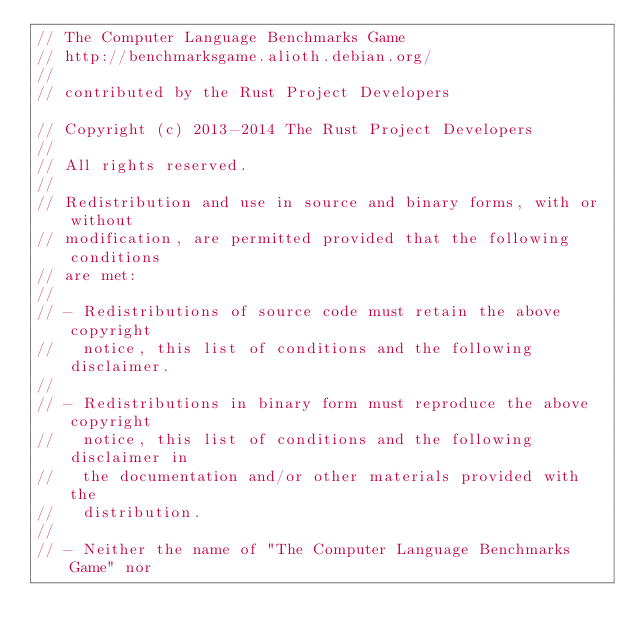Convert code to text. <code><loc_0><loc_0><loc_500><loc_500><_Rust_>// The Computer Language Benchmarks Game
// http://benchmarksgame.alioth.debian.org/
//
// contributed by the Rust Project Developers

// Copyright (c) 2013-2014 The Rust Project Developers
//
// All rights reserved.
//
// Redistribution and use in source and binary forms, with or without
// modification, are permitted provided that the following conditions
// are met:
//
// - Redistributions of source code must retain the above copyright
//   notice, this list of conditions and the following disclaimer.
//
// - Redistributions in binary form must reproduce the above copyright
//   notice, this list of conditions and the following disclaimer in
//   the documentation and/or other materials provided with the
//   distribution.
//
// - Neither the name of "The Computer Language Benchmarks Game" nor</code> 